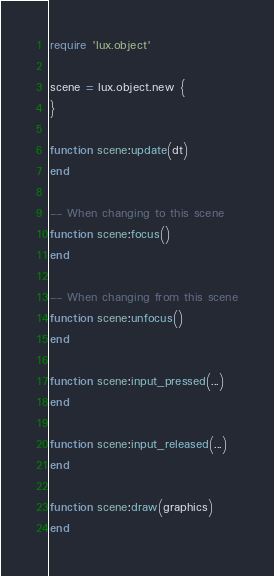Convert code to text. <code><loc_0><loc_0><loc_500><loc_500><_Lua_>
require 'lux.object'

scene = lux.object.new {
}

function scene:update(dt)
end

-- When changing to this scene
function scene:focus()
end

-- When changing from this scene
function scene:unfocus()
end

function scene:input_pressed(...)
end

function scene:input_released(...)
end

function scene:draw(graphics)
end
</code> 